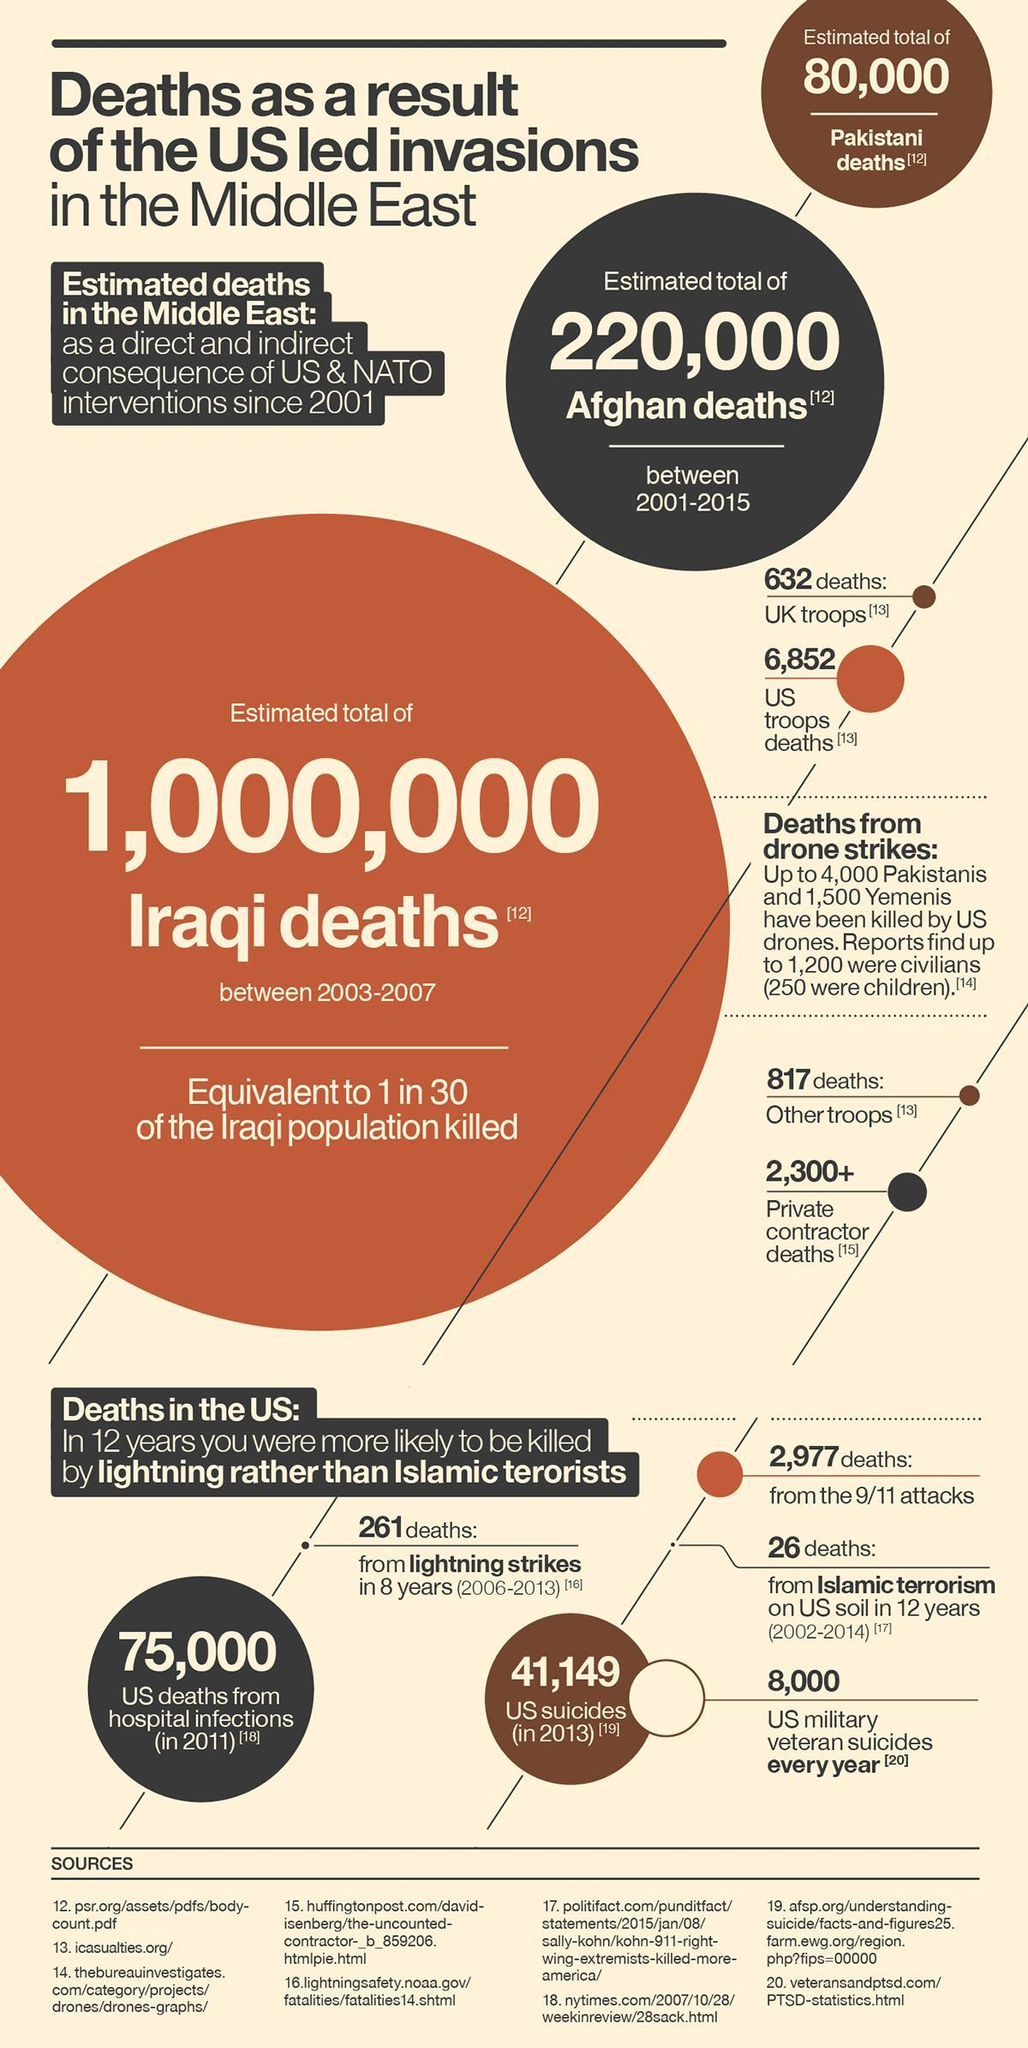How many people in the US were died due to lightning strikes?
Answer the question with a short phrase. 261 deaths 